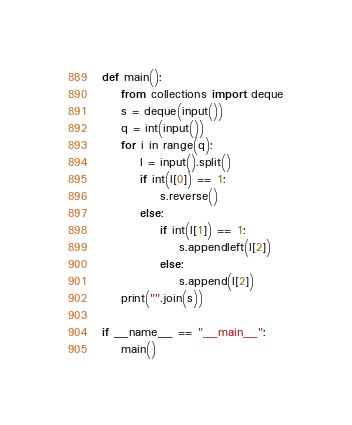Convert code to text. <code><loc_0><loc_0><loc_500><loc_500><_Python_>def main():
    from collections import deque
    s = deque(input())
    q = int(input())
    for i in range(q):
        l = input().split()
        if int(l[0]) == 1:
            s.reverse()
        else:
            if int(l[1]) == 1:
                s.appendleft(l[2])
            else:
                s.append(l[2])
    print("".join(s))

if __name__ == "__main__":
    main()</code> 